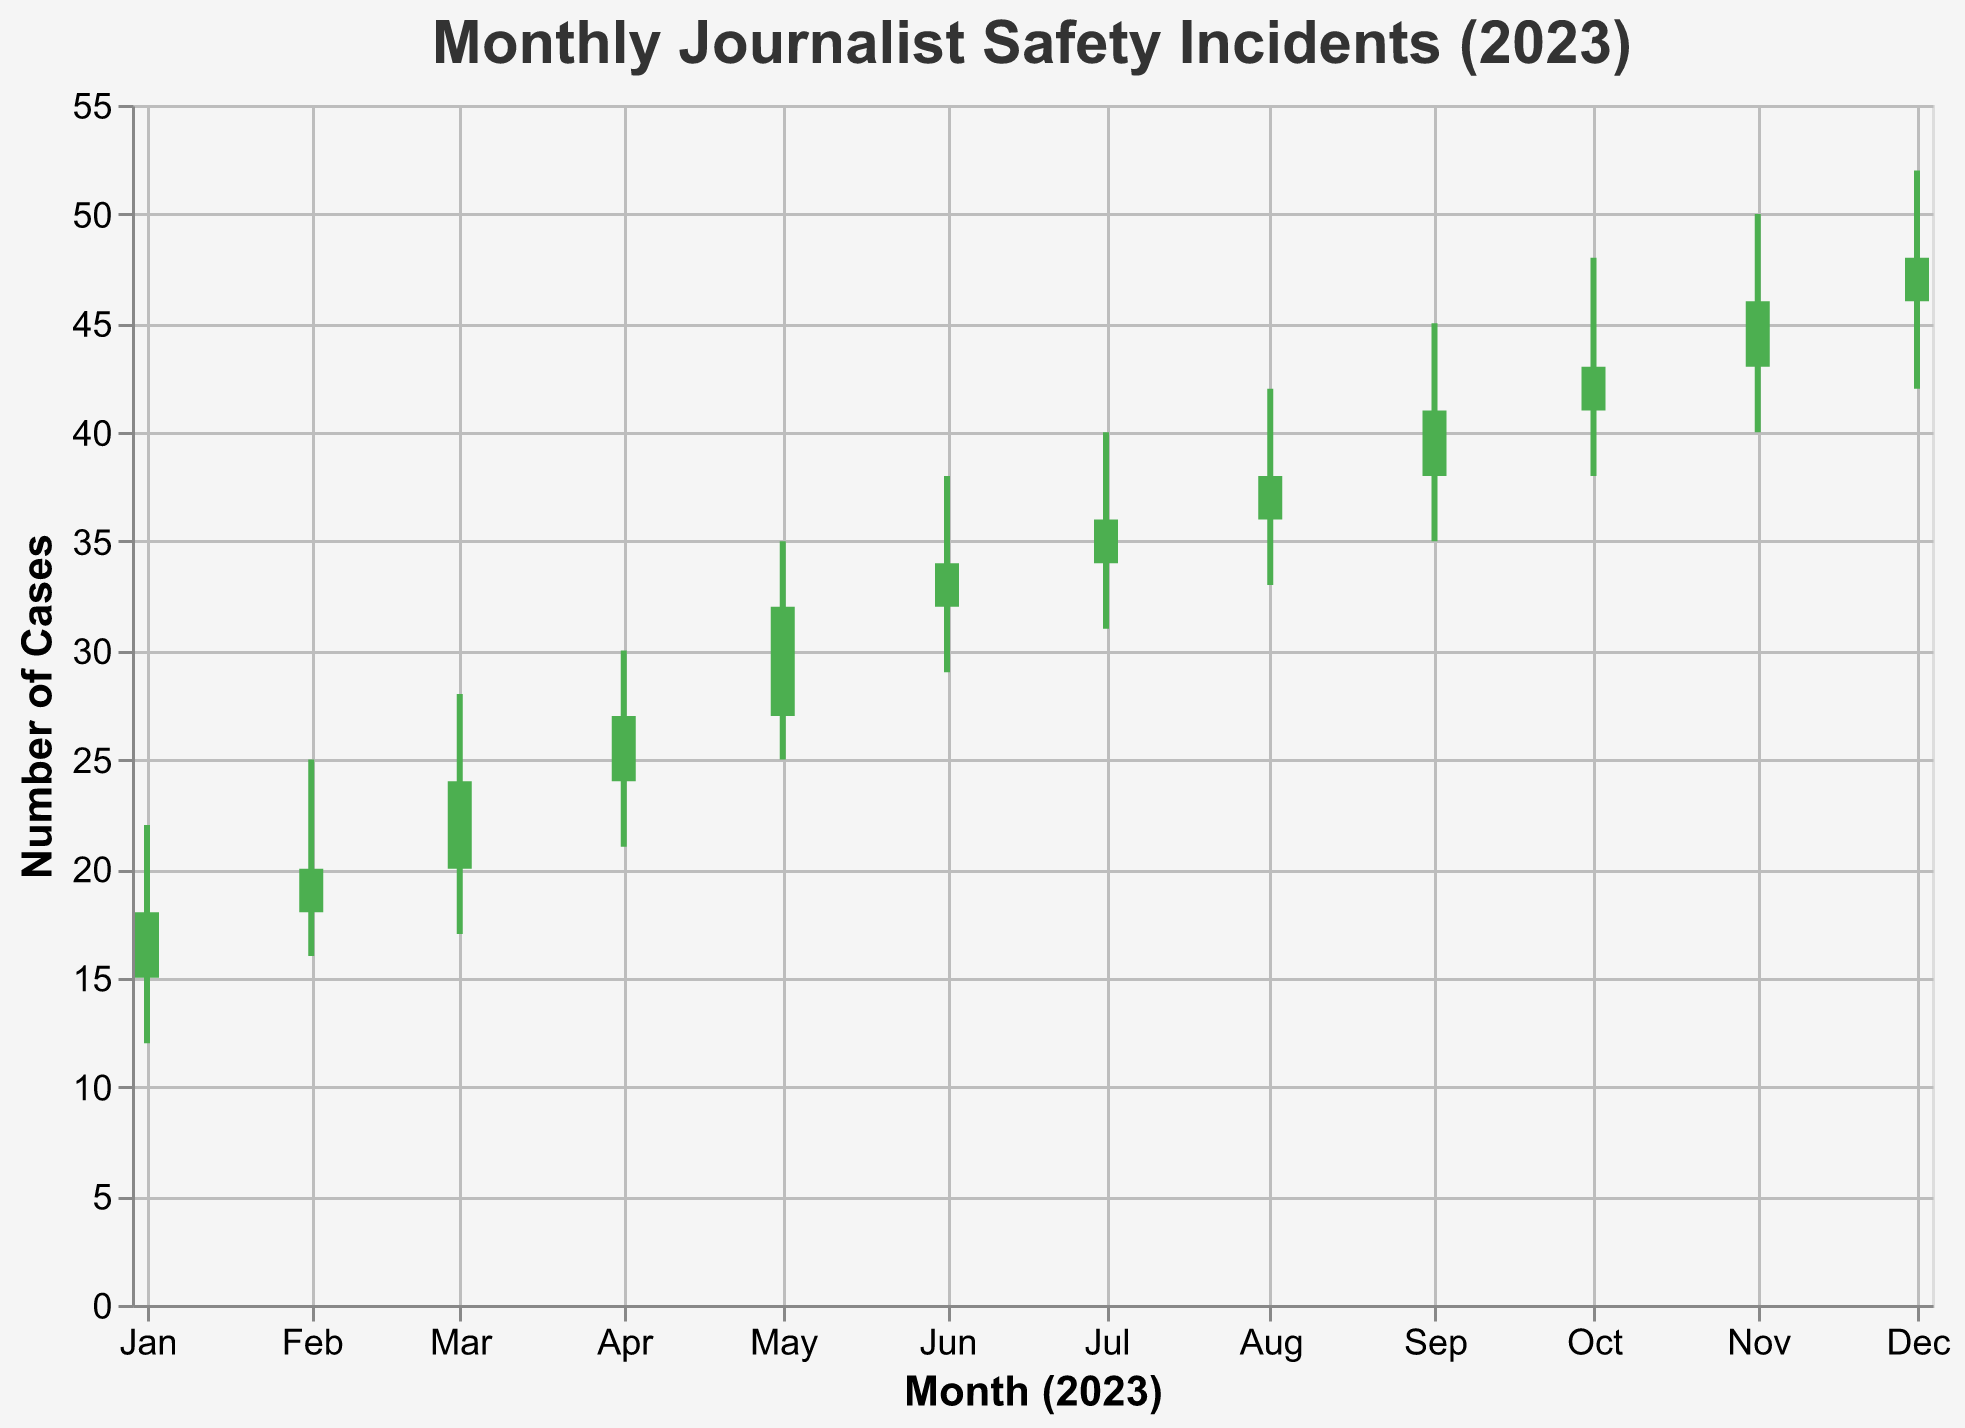What's the title of the chart? The title is written at the top of the chart, describing what the data represents and the time frame.
Answer: Monthly Journalist Safety Incidents (2023) What does the y-axis represent in the chart? The y-axis title is shown and it indicates the measurement being plotted vertically.
Answer: Number of Cases Which month has the highest number of reported cases? By looking at the 'High' values corresponding to each month, we identify the peak value which indicates the highest reported cases. In October, the 'High' value is 48, which is the highest among all months.
Answer: October 2023 In which month was the highest number of cases resolved? The 'Resolved Cases' per month can be compared and the maximum value can be identified. December shows the highest resolved cases with 45.
Answer: December 2023 How many months had an increase in safety incidents from the opening to the closing value? By examining the color of the bars, which are green if the close value is higher than the open, we count the instances.
Answer: 12 What is the average number of resolved cases over the year? Add up all the resolved case numbers and divide by the number of months: (15 + 18 + 22 + 25 + 28 + 31 + 33 + 35 + 37 + 40 + 42 + 45)/12 = 33
Answer: 33 During which month was the risk for journalists the lowest? By finding the minimum 'Low' value, we can determine the month with the lowest risk period. January had the 'Low' value of 12, the lowest in the chart.
Answer: January 2023 Which months saw the largest increase from their opening to closing values? By subtracting the 'Open' values from the 'Close' values for each month, the month with the highest difference is October (43-41 = 2).
Answer: October 2023 What was the number of reported cases in September? The value corresponding to 'Reported Cases' in September is directly shown.
Answer: 45 